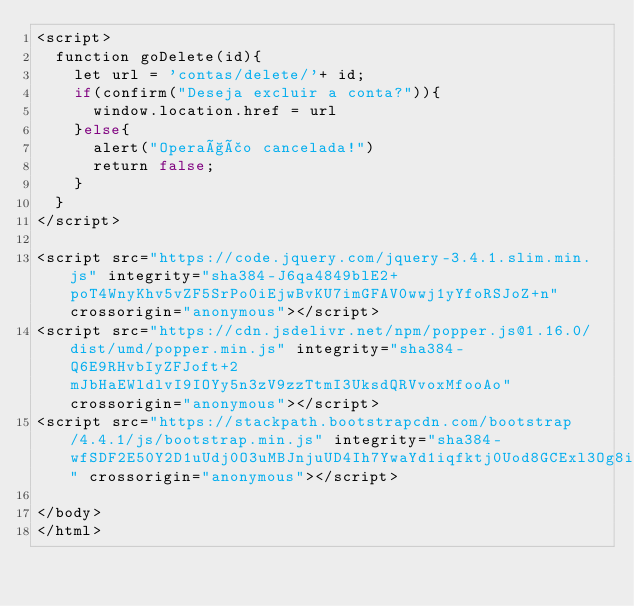<code> <loc_0><loc_0><loc_500><loc_500><_PHP_><script>
	function goDelete(id){
		let url = 'contas/delete/'+ id;
		if(confirm("Deseja excluir a conta?")){
			window.location.href = url
		}else{
			alert("Operação cancelada!")
			return false;
		}
	}
</script>

<script src="https://code.jquery.com/jquery-3.4.1.slim.min.js" integrity="sha384-J6qa4849blE2+poT4WnyKhv5vZF5SrPo0iEjwBvKU7imGFAV0wwj1yYfoRSJoZ+n" crossorigin="anonymous"></script>
<script src="https://cdn.jsdelivr.net/npm/popper.js@1.16.0/dist/umd/popper.min.js" integrity="sha384-Q6E9RHvbIyZFJoft+2mJbHaEWldlvI9IOYy5n3zV9zzTtmI3UksdQRVvoxMfooAo" crossorigin="anonymous"></script>
<script src="https://stackpath.bootstrapcdn.com/bootstrap/4.4.1/js/bootstrap.min.js" integrity="sha384-wfSDF2E50Y2D1uUdj0O3uMBJnjuUD4Ih7YwaYd1iqfktj0Uod8GCExl3Og8ifwB6" crossorigin="anonymous"></script>

</body>
</html>
</code> 